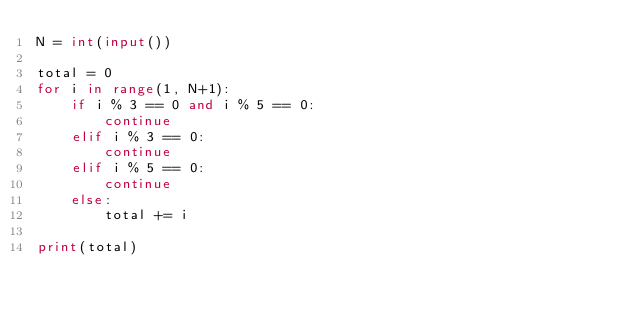Convert code to text. <code><loc_0><loc_0><loc_500><loc_500><_Python_>N = int(input())

total = 0
for i in range(1, N+1):
    if i % 3 == 0 and i % 5 == 0:
        continue
    elif i % 3 == 0:
        continue
    elif i % 5 == 0:
        continue
    else:
        total += i

print(total)</code> 